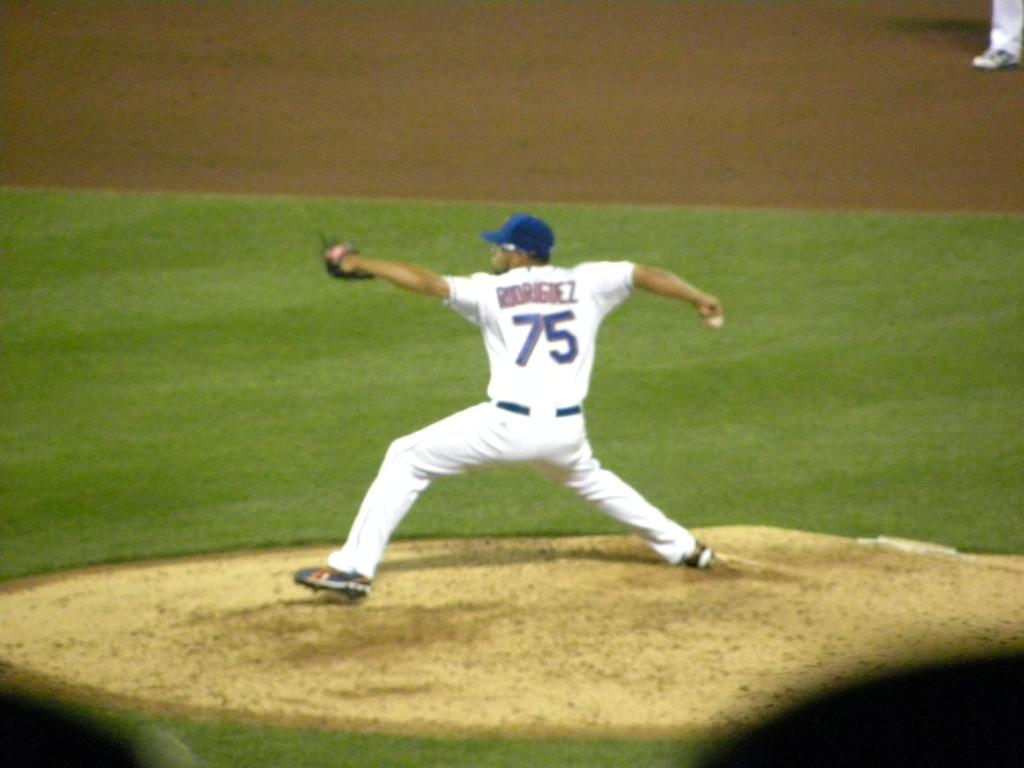Provide a one-sentence caption for the provided image. Baseball player wearing number 75 pitching the baseball. 